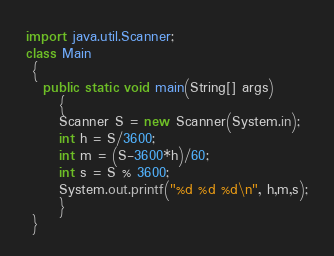<code> <loc_0><loc_0><loc_500><loc_500><_Java_>import java.util.Scanner;
class Main
 {
   public static void main(String[] args)
      {
      Scanner S = new Scanner(System.in);
      int h = S/3600;
      int m = (S-3600*h)/60;
      int s = S % 3600;
      System.out.printf("%d %d %d\n", h,m,s);
      }
 }

</code> 